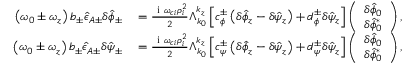<formula> <loc_0><loc_0><loc_500><loc_500>\begin{array} { r l } { \left ( \omega _ { 0 } \pm \omega _ { z } \right ) b _ { \pm } \hat { \epsilon } _ { A \pm } \delta \hat { \phi } _ { \pm } } & = \frac { i \omega _ { c i } \rho _ { i } ^ { 2 } } { 2 } \Lambda _ { k _ { 0 } } ^ { k _ { z } } \left [ c _ { \phi } ^ { \pm } \left ( \delta \hat { \phi } _ { z } - \delta \hat { \psi } _ { z } \right ) + d _ { \phi } ^ { \pm } \delta \hat { \psi } _ { z } \right ] \left ( \begin{array} { c } { \delta \hat { \phi } _ { 0 } } \\ { \delta \hat { \phi } _ { 0 } ^ { * } } \end{array} \right ) , } \\ { \left ( \omega _ { 0 } \pm \omega _ { z } \right ) b _ { \pm } \hat { \epsilon } _ { A \pm } \delta \hat { \psi } _ { \pm } } & = \frac { i \omega _ { c i } \rho _ { i } ^ { 2 } } { 2 } \Lambda _ { k _ { 0 } } ^ { k _ { z } } \left [ c _ { \psi } ^ { \pm } \left ( \delta \hat { \phi } _ { z } - \delta \hat { \psi } _ { z } \right ) + d _ { \psi } ^ { \pm } \delta \hat { \psi } _ { z } \right ] \left ( \begin{array} { c } { \delta \hat { \phi } _ { 0 } } \\ { \delta \hat { \phi } _ { 0 } ^ { * } } \end{array} \right ) , } \end{array}</formula> 